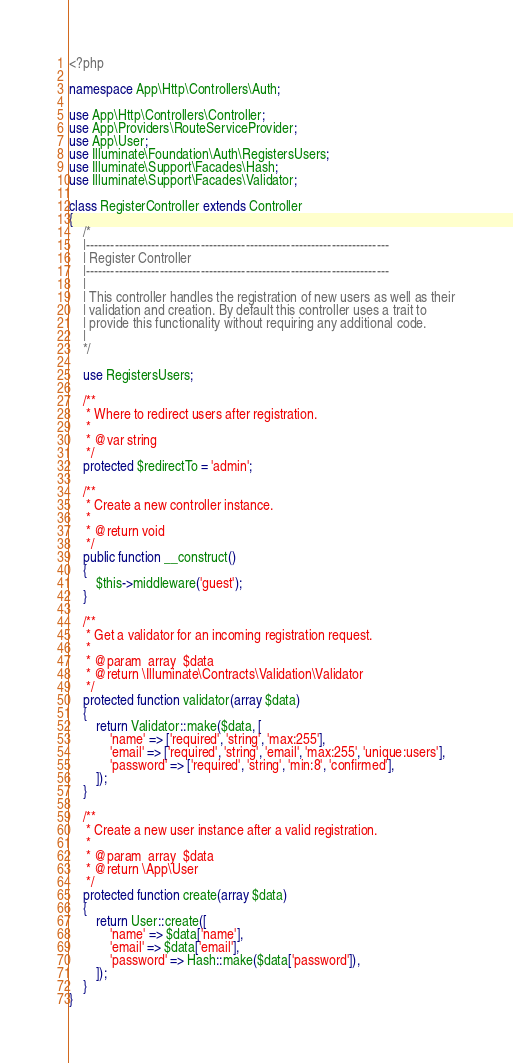Convert code to text. <code><loc_0><loc_0><loc_500><loc_500><_PHP_><?php

namespace App\Http\Controllers\Auth;

use App\Http\Controllers\Controller;
use App\Providers\RouteServiceProvider;
use App\User;
use Illuminate\Foundation\Auth\RegistersUsers;
use Illuminate\Support\Facades\Hash;
use Illuminate\Support\Facades\Validator;

class RegisterController extends Controller
{
    /*
    |--------------------------------------------------------------------------
    | Register Controller
    |--------------------------------------------------------------------------
    |
    | This controller handles the registration of new users as well as their
    | validation and creation. By default this controller uses a trait to
    | provide this functionality without requiring any additional code.
    |
    */

    use RegistersUsers;

    /**
     * Where to redirect users after registration.
     *
     * @var string
     */
    protected $redirectTo = 'admin';

    /**
     * Create a new controller instance.
     *
     * @return void
     */
    public function __construct()
    {
        $this->middleware('guest');
    }

    /**
     * Get a validator for an incoming registration request.
     *
     * @param  array  $data
     * @return \Illuminate\Contracts\Validation\Validator
     */
    protected function validator(array $data)
    {
        return Validator::make($data, [
            'name' => ['required', 'string', 'max:255'],
            'email' => ['required', 'string', 'email', 'max:255', 'unique:users'],
            'password' => ['required', 'string', 'min:8', 'confirmed'],
        ]);
    }

    /**
     * Create a new user instance after a valid registration.
     *
     * @param  array  $data
     * @return \App\User
     */
    protected function create(array $data)
    {
        return User::create([
            'name' => $data['name'],
            'email' => $data['email'],
            'password' => Hash::make($data['password']),
        ]);
    }
}
</code> 